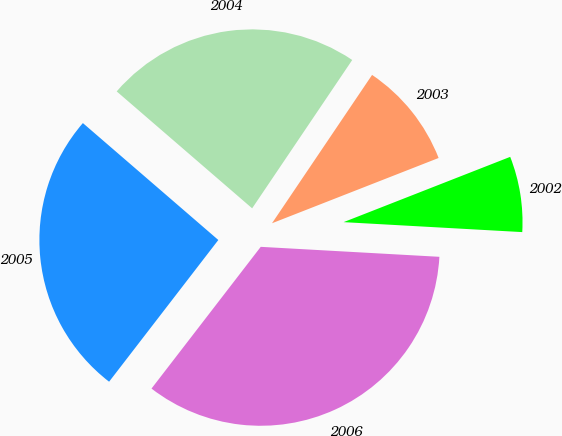Convert chart. <chart><loc_0><loc_0><loc_500><loc_500><pie_chart><fcel>2006<fcel>2005<fcel>2004<fcel>2003<fcel>2002<nl><fcel>34.56%<fcel>25.88%<fcel>23.11%<fcel>9.61%<fcel>6.83%<nl></chart> 